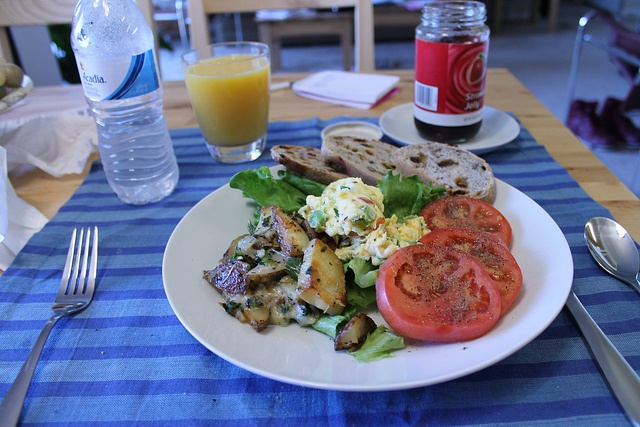Describe the objects in this image and their specific colors. I can see dining table in gray, darkgray, and blue tones, chair in gray, darkgray, and lightblue tones, bottle in gray, darkgray, and lavender tones, bottle in gray, maroon, black, and darkgray tones, and chair in gray, blue, black, navy, and darkblue tones in this image. 